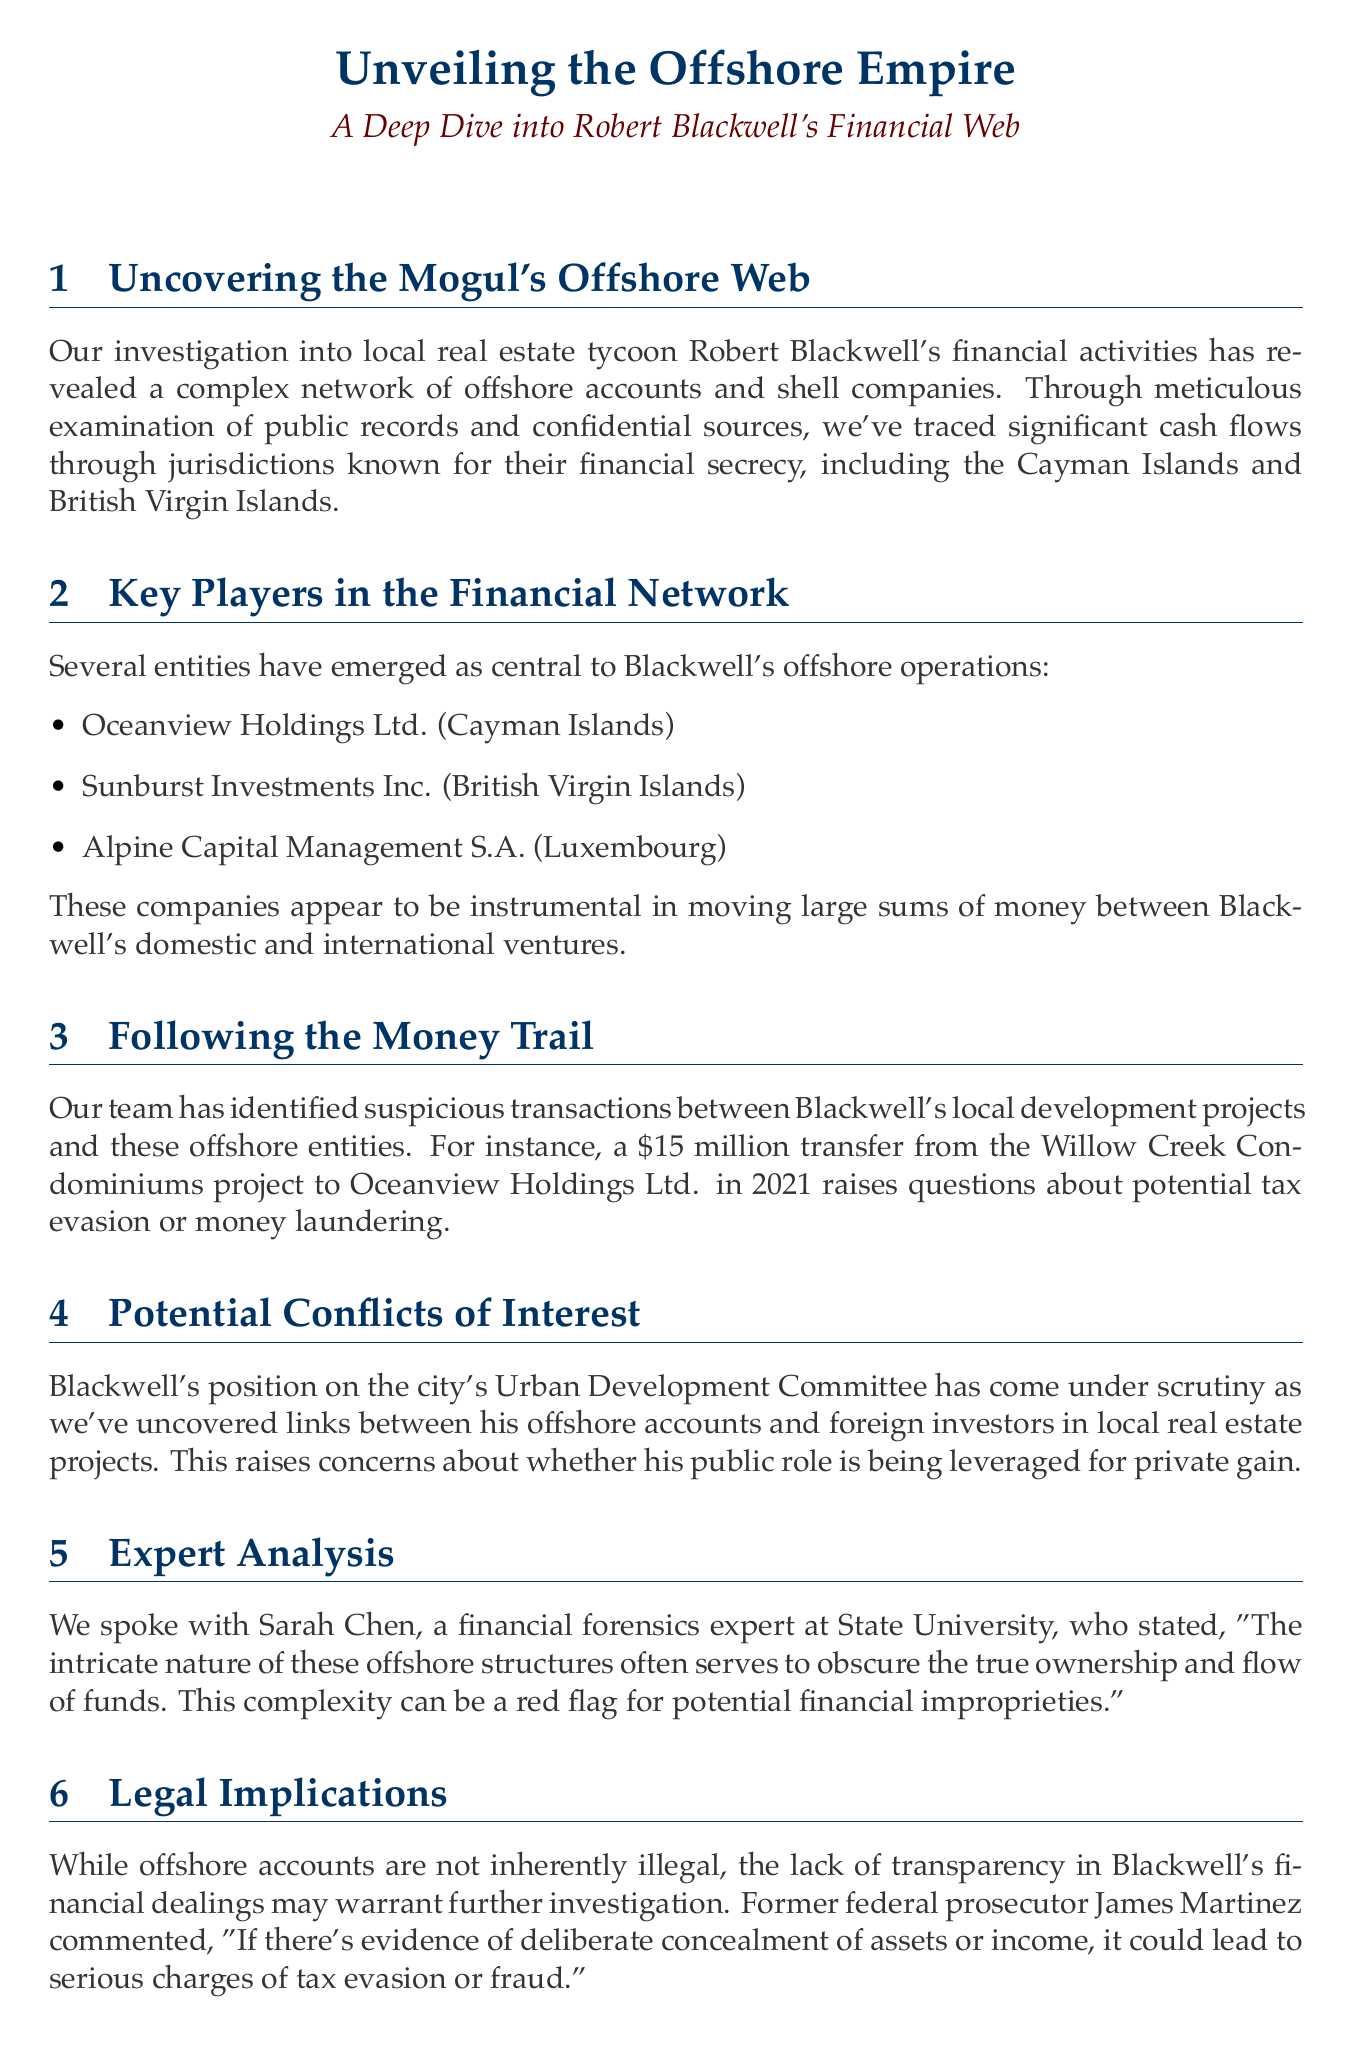What is the name of the real estate mogul investigated? The document mentions the individual being investigated as Robert Blackwell.
Answer: Robert Blackwell What are two offshore jurisdictions mentioned in the newsletter? The document lists the Cayman Islands and British Virgin Islands as jurisdictions known for financial secrecy.
Answer: Cayman Islands, British Virgin Islands How much money was transferred from the Willow Creek Condominiums project? A specific transaction amount is mentioned as $15 million.
Answer: $15 million Who is the financial forensics expert quoted in the newsletter? The document attributes a quote to Sarah Chen, who is a financial forensics expert at State University.
Answer: Sarah Chen What committee position does Blackwell hold? The text specifies that Blackwell is on the city's Urban Development Committee.
Answer: Urban Development Committee What concern is raised about Blackwell's public role? The newsletter raises concerns regarding potential leveraging of his public role for private gain.
Answer: Private gain What is the next step in the investigation mentioned in the document? The document states that the team is pursuing leads on additional shell companies linked to Blackwell's operations in Panama and Malta.
Answer: Additional shell companies What did former federal prosecutor James Martinez comment about the legality of offshore accounts? The comment reflects that offshore accounts are not inherently illegal but may require further investigation.
Answer: Not inherently illegal What year did the suspicious transaction occur? The document specifies that the $15 million transfer took place in 2021.
Answer: 2021 